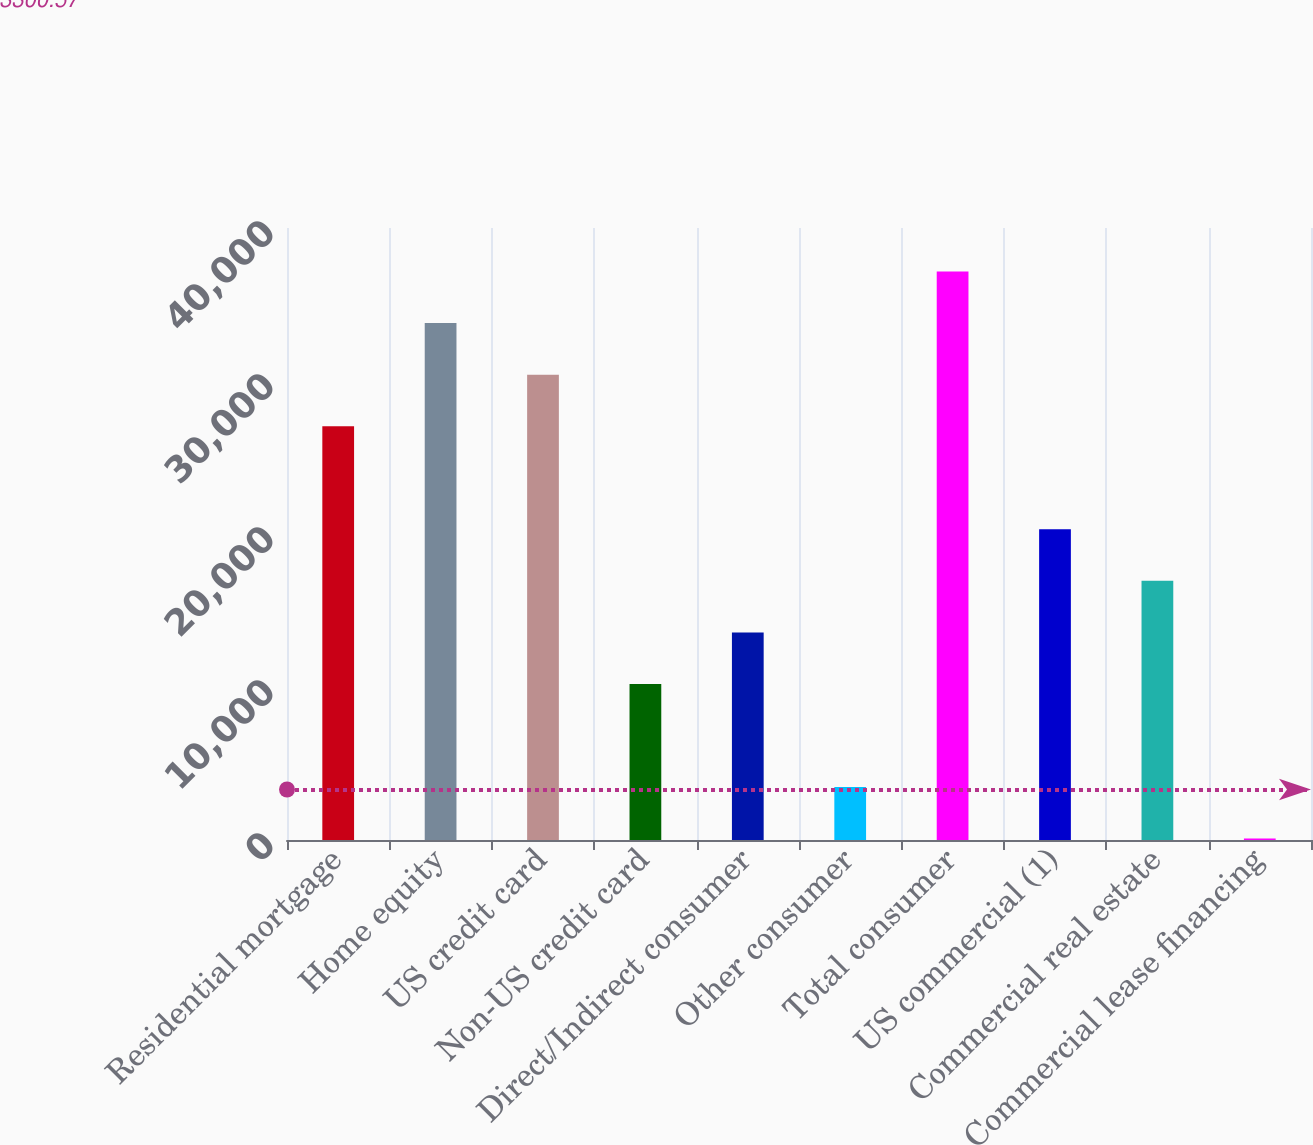Convert chart to OTSL. <chart><loc_0><loc_0><loc_500><loc_500><bar_chart><fcel>Residential mortgage<fcel>Home equity<fcel>US credit card<fcel>Non-US credit card<fcel>Direct/Indirect consumer<fcel>Other consumer<fcel>Total consumer<fcel>US commercial (1)<fcel>Commercial real estate<fcel>Commercial lease financing<nl><fcel>27044.8<fcel>33783<fcel>30413.9<fcel>10199.3<fcel>13568.4<fcel>3461.1<fcel>37152.1<fcel>20306.6<fcel>16937.5<fcel>92<nl></chart> 